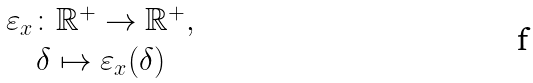<formula> <loc_0><loc_0><loc_500><loc_500>\begin{array} { c } \varepsilon _ { x } \colon \mathbb { R } ^ { + } \to \mathbb { R } ^ { + } , \\ \delta \mapsto \varepsilon _ { x } ( \delta ) \end{array}</formula> 